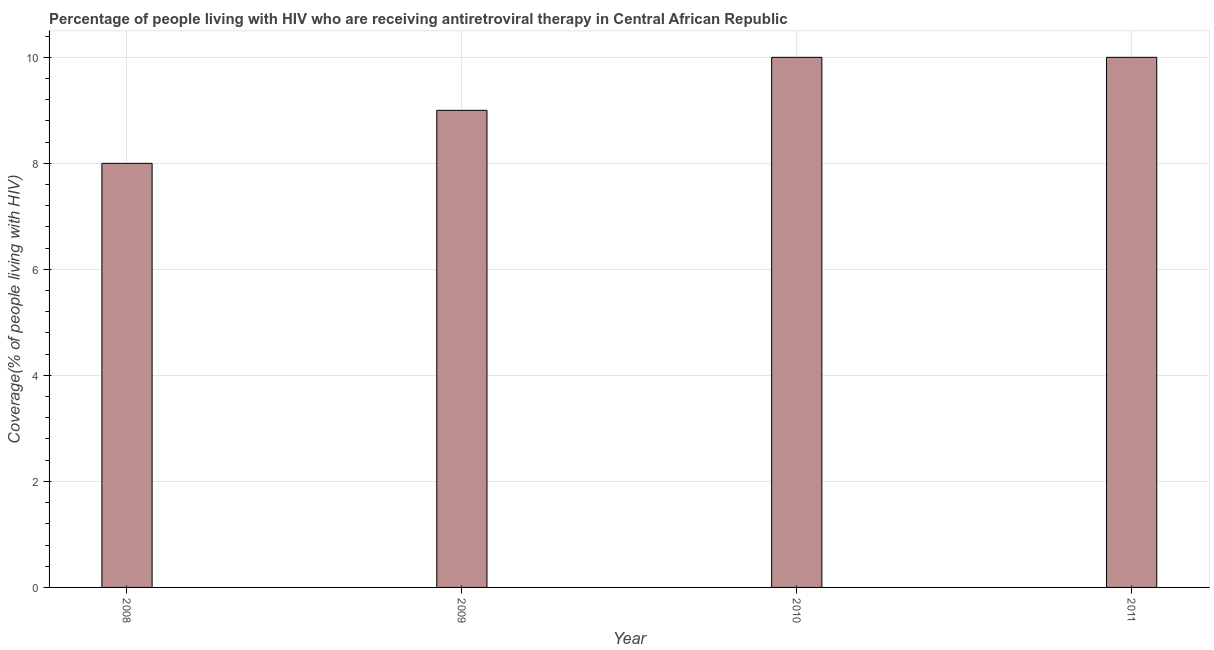Does the graph contain grids?
Your answer should be very brief. Yes. What is the title of the graph?
Your answer should be very brief. Percentage of people living with HIV who are receiving antiretroviral therapy in Central African Republic. What is the label or title of the Y-axis?
Your answer should be compact. Coverage(% of people living with HIV). What is the antiretroviral therapy coverage in 2011?
Your answer should be compact. 10. Across all years, what is the minimum antiretroviral therapy coverage?
Provide a succinct answer. 8. In which year was the antiretroviral therapy coverage minimum?
Offer a terse response. 2008. What is the sum of the antiretroviral therapy coverage?
Your response must be concise. 37. Do a majority of the years between 2009 and 2010 (inclusive) have antiretroviral therapy coverage greater than 0.8 %?
Your answer should be compact. Yes. Is the difference between the antiretroviral therapy coverage in 2010 and 2011 greater than the difference between any two years?
Ensure brevity in your answer.  No. Is the sum of the antiretroviral therapy coverage in 2009 and 2011 greater than the maximum antiretroviral therapy coverage across all years?
Your answer should be compact. Yes. What is the difference between the highest and the lowest antiretroviral therapy coverage?
Provide a short and direct response. 2. In how many years, is the antiretroviral therapy coverage greater than the average antiretroviral therapy coverage taken over all years?
Ensure brevity in your answer.  2. How many bars are there?
Make the answer very short. 4. Are all the bars in the graph horizontal?
Ensure brevity in your answer.  No. How many years are there in the graph?
Your response must be concise. 4. What is the difference between two consecutive major ticks on the Y-axis?
Make the answer very short. 2. What is the Coverage(% of people living with HIV) of 2010?
Offer a very short reply. 10. What is the Coverage(% of people living with HIV) of 2011?
Provide a succinct answer. 10. What is the difference between the Coverage(% of people living with HIV) in 2008 and 2009?
Give a very brief answer. -1. What is the difference between the Coverage(% of people living with HIV) in 2008 and 2010?
Your response must be concise. -2. What is the difference between the Coverage(% of people living with HIV) in 2008 and 2011?
Your answer should be compact. -2. What is the difference between the Coverage(% of people living with HIV) in 2009 and 2011?
Your answer should be very brief. -1. What is the ratio of the Coverage(% of people living with HIV) in 2008 to that in 2009?
Your answer should be very brief. 0.89. What is the ratio of the Coverage(% of people living with HIV) in 2008 to that in 2010?
Your answer should be compact. 0.8. What is the ratio of the Coverage(% of people living with HIV) in 2009 to that in 2010?
Provide a short and direct response. 0.9. What is the ratio of the Coverage(% of people living with HIV) in 2009 to that in 2011?
Your answer should be very brief. 0.9. What is the ratio of the Coverage(% of people living with HIV) in 2010 to that in 2011?
Your answer should be very brief. 1. 